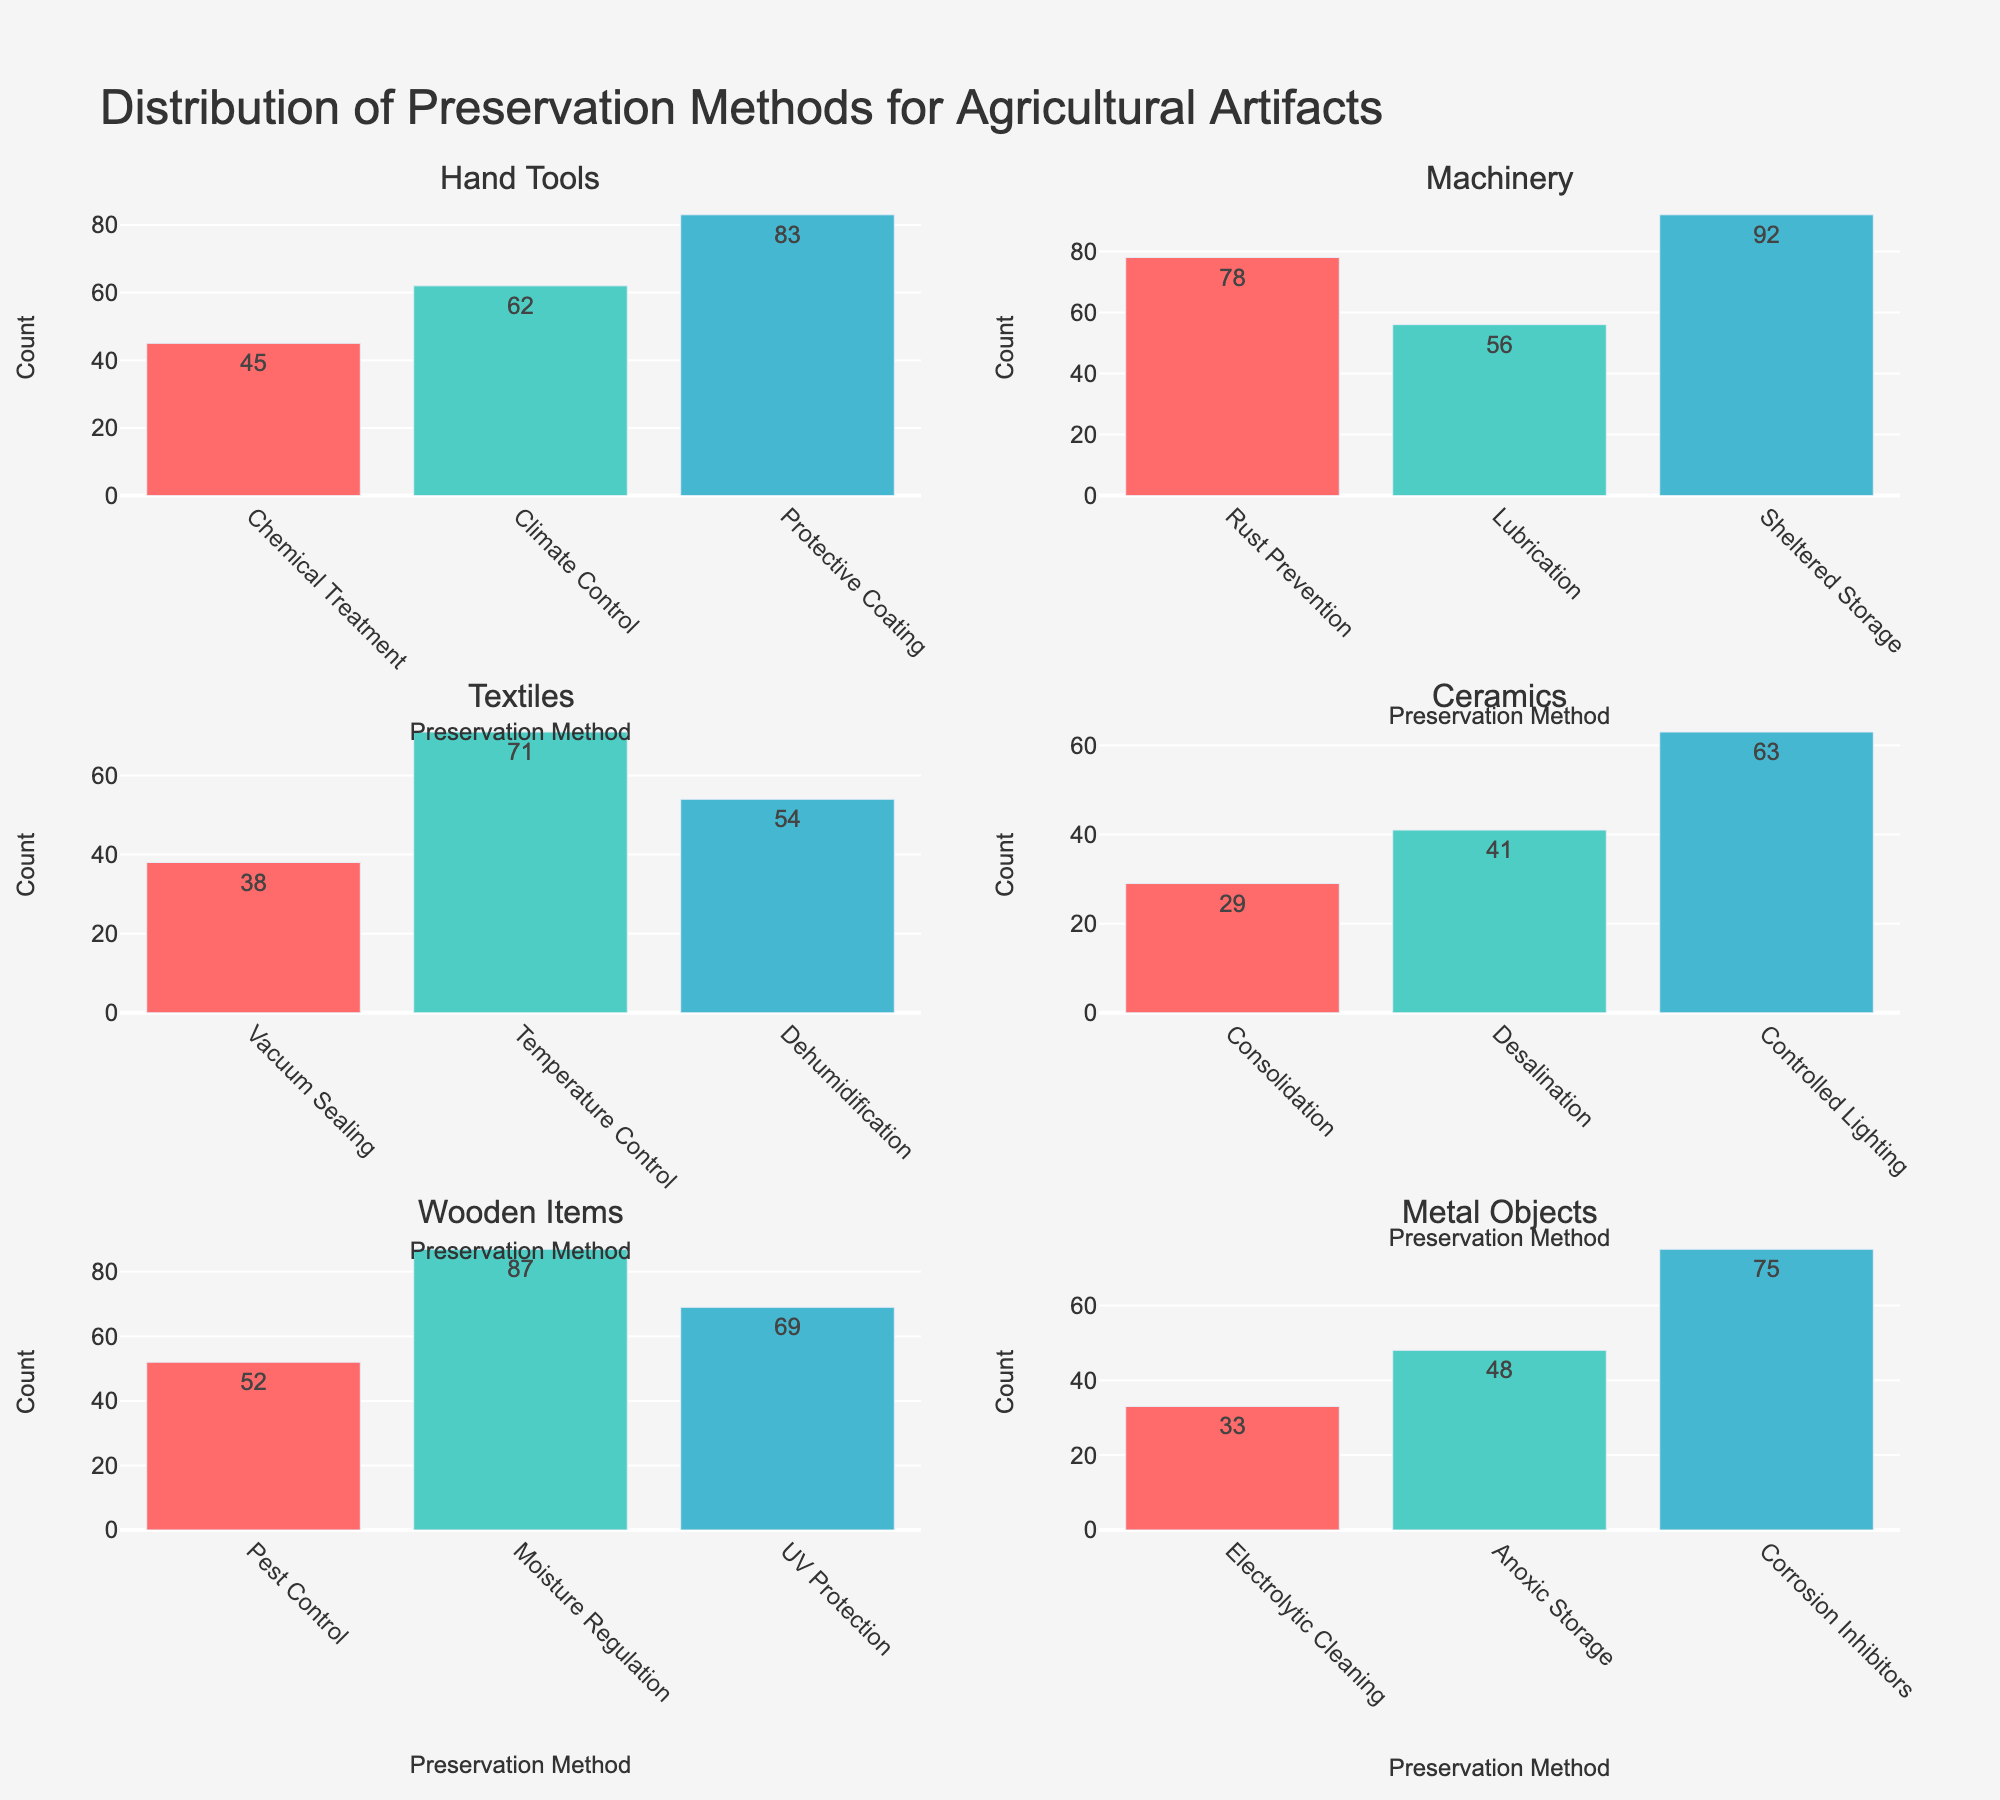What is the title of the figure? The title is usually displayed prominently at the top of the figure. For this specific plot, it should indicate what the data is about.
Answer: Distribution of Preservation Methods for Agricultural Artifacts How many preservation methods are used for Hand Tools? Locate the subplot titled "Hand Tools" and count the number of bars, each representing a different preservation method.
Answer: 3 Which preservation method is most common for Machinery? Find the subplot for "Machinery". Identify the highest bar, which shows the preservation method with the largest count.
Answer: Sheltered Storage What is the combined count of Chemical Treatment and Climate Control for Hand Tools? Look at the subplot for Hand Tools and find the bars for Chemical Treatment and Climate Control. Sum the counts given on the bars.
Answer: 107 Which category uses Electrolytic Cleaning as a preservation method? Check each subplot to see where the term "Electrolytic Cleaning" appears on the x-axis, indicating which category it belongs to.
Answer: Metal Objects How does the use of Dehumidification for Textiles compare to Desalination for Ceramics? Find the "Textiles" subplot and the corresponding bar for Dehumidification and the "Ceramics" subplot for Desalination. Compare the heights or counts directly.
Answer: Dehumidification is higher What is the average count of preservation methods applied to Wooden Items? For the "Wooden Items" subplot, list the counts for all preservation methods, sum them up, and divide by the number of methods. [(52 + 87 + 69) / 3]
Answer: 69.33 Which preservation method has the lowest count and for which category? Identify the shortest bar across all subplots and see which preservation method and category it belongs to.
Answer: Consolidation (Ceramics) How many preservation methods are applied to Metal Objects in total? In the "Metal Objects" subplot, sum the heights of all the bars.
Answer: 156 Is there any preservation method used across all categories? Check each subplot to see if any preservation method appears in all subplots, indicating its universal application.
Answer: No 